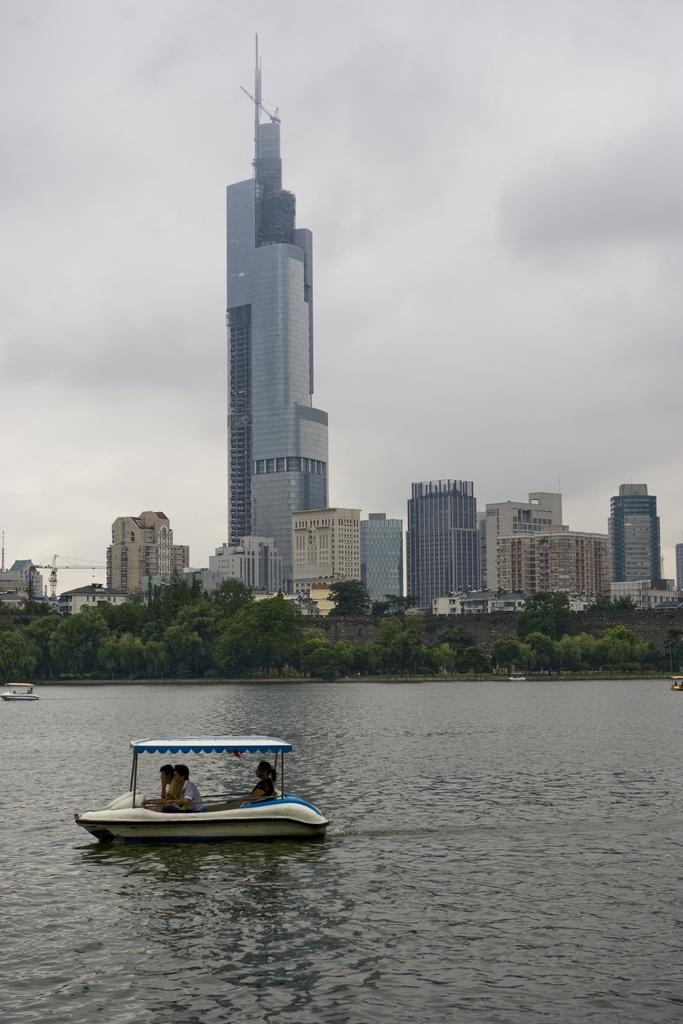What are the people in the image doing? The people in the image are sitting in a boat. What can be seen in the background of the image? There are buildings visible in the image. What else is present in the image besides the boat and people? Plants are present in the image. What is the primary setting of the image? There is water visible in the image, and the people are sitting in a boat, so the primary setting is likely a body of water. What is visible above the boat and people in the image? The sky is visible in the image. Is there a zoo visible in the image? No, there is no zoo present in the image. What type of frame is used to display the image? The question about the frame is not relevant to the image itself, as it refers to the physical presentation of the image rather than its content. 